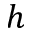<formula> <loc_0><loc_0><loc_500><loc_500>h</formula> 